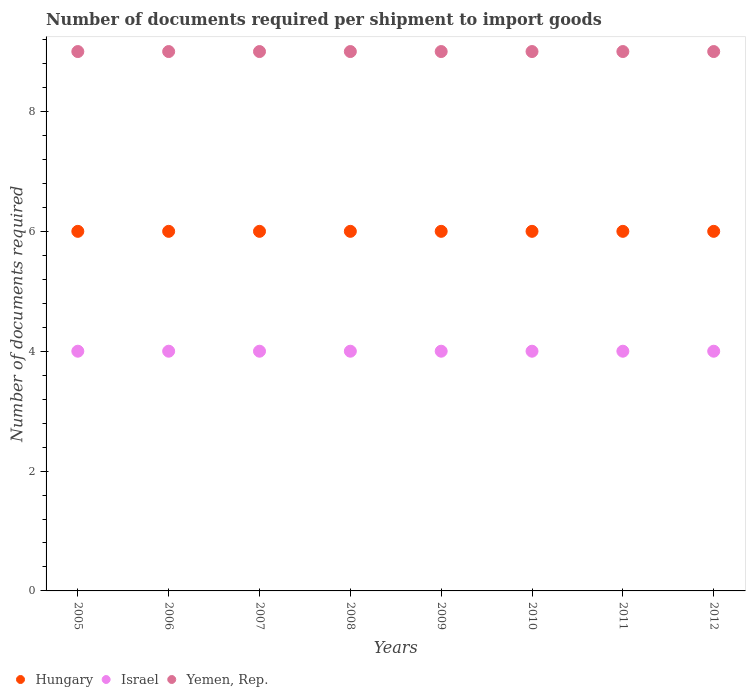Is the number of dotlines equal to the number of legend labels?
Provide a succinct answer. Yes. What is the number of documents required per shipment to import goods in Yemen, Rep. in 2012?
Give a very brief answer. 9. Across all years, what is the maximum number of documents required per shipment to import goods in Yemen, Rep.?
Make the answer very short. 9. Across all years, what is the minimum number of documents required per shipment to import goods in Israel?
Your answer should be compact. 4. In which year was the number of documents required per shipment to import goods in Yemen, Rep. maximum?
Offer a very short reply. 2005. What is the total number of documents required per shipment to import goods in Hungary in the graph?
Make the answer very short. 48. What is the difference between the number of documents required per shipment to import goods in Hungary in 2008 and that in 2010?
Provide a succinct answer. 0. What is the difference between the number of documents required per shipment to import goods in Yemen, Rep. in 2011 and the number of documents required per shipment to import goods in Hungary in 2009?
Provide a short and direct response. 3. What is the average number of documents required per shipment to import goods in Hungary per year?
Give a very brief answer. 6. In the year 2006, what is the difference between the number of documents required per shipment to import goods in Hungary and number of documents required per shipment to import goods in Yemen, Rep.?
Ensure brevity in your answer.  -3. Is the difference between the number of documents required per shipment to import goods in Hungary in 2005 and 2007 greater than the difference between the number of documents required per shipment to import goods in Yemen, Rep. in 2005 and 2007?
Offer a terse response. No. What is the difference between the highest and the second highest number of documents required per shipment to import goods in Israel?
Your answer should be compact. 0. What is the difference between the highest and the lowest number of documents required per shipment to import goods in Hungary?
Provide a succinct answer. 0. In how many years, is the number of documents required per shipment to import goods in Israel greater than the average number of documents required per shipment to import goods in Israel taken over all years?
Provide a short and direct response. 0. Is the sum of the number of documents required per shipment to import goods in Yemen, Rep. in 2006 and 2008 greater than the maximum number of documents required per shipment to import goods in Israel across all years?
Provide a short and direct response. Yes. Does the number of documents required per shipment to import goods in Israel monotonically increase over the years?
Give a very brief answer. No. Are the values on the major ticks of Y-axis written in scientific E-notation?
Your response must be concise. No. Does the graph contain any zero values?
Make the answer very short. No. How many legend labels are there?
Ensure brevity in your answer.  3. How are the legend labels stacked?
Provide a short and direct response. Horizontal. What is the title of the graph?
Ensure brevity in your answer.  Number of documents required per shipment to import goods. What is the label or title of the X-axis?
Offer a very short reply. Years. What is the label or title of the Y-axis?
Offer a very short reply. Number of documents required. What is the Number of documents required of Hungary in 2005?
Your answer should be compact. 6. What is the Number of documents required in Yemen, Rep. in 2005?
Ensure brevity in your answer.  9. What is the Number of documents required in Hungary in 2006?
Your answer should be very brief. 6. What is the Number of documents required in Israel in 2006?
Keep it short and to the point. 4. What is the Number of documents required in Yemen, Rep. in 2006?
Your answer should be compact. 9. What is the Number of documents required of Hungary in 2008?
Your response must be concise. 6. What is the Number of documents required in Israel in 2008?
Ensure brevity in your answer.  4. What is the Number of documents required of Israel in 2010?
Provide a short and direct response. 4. Across all years, what is the maximum Number of documents required of Israel?
Provide a succinct answer. 4. Across all years, what is the maximum Number of documents required in Yemen, Rep.?
Offer a very short reply. 9. Across all years, what is the minimum Number of documents required in Hungary?
Your answer should be very brief. 6. Across all years, what is the minimum Number of documents required of Israel?
Keep it short and to the point. 4. Across all years, what is the minimum Number of documents required in Yemen, Rep.?
Your answer should be compact. 9. What is the total Number of documents required in Yemen, Rep. in the graph?
Your answer should be very brief. 72. What is the difference between the Number of documents required of Yemen, Rep. in 2005 and that in 2006?
Provide a short and direct response. 0. What is the difference between the Number of documents required of Hungary in 2005 and that in 2007?
Give a very brief answer. 0. What is the difference between the Number of documents required of Israel in 2005 and that in 2007?
Provide a short and direct response. 0. What is the difference between the Number of documents required in Hungary in 2005 and that in 2008?
Offer a very short reply. 0. What is the difference between the Number of documents required of Israel in 2005 and that in 2008?
Make the answer very short. 0. What is the difference between the Number of documents required in Yemen, Rep. in 2005 and that in 2008?
Give a very brief answer. 0. What is the difference between the Number of documents required in Yemen, Rep. in 2005 and that in 2009?
Make the answer very short. 0. What is the difference between the Number of documents required in Hungary in 2005 and that in 2010?
Your response must be concise. 0. What is the difference between the Number of documents required in Yemen, Rep. in 2005 and that in 2010?
Give a very brief answer. 0. What is the difference between the Number of documents required of Hungary in 2005 and that in 2011?
Provide a succinct answer. 0. What is the difference between the Number of documents required of Israel in 2005 and that in 2011?
Offer a very short reply. 0. What is the difference between the Number of documents required of Hungary in 2005 and that in 2012?
Ensure brevity in your answer.  0. What is the difference between the Number of documents required in Yemen, Rep. in 2005 and that in 2012?
Give a very brief answer. 0. What is the difference between the Number of documents required of Hungary in 2006 and that in 2007?
Ensure brevity in your answer.  0. What is the difference between the Number of documents required in Yemen, Rep. in 2006 and that in 2007?
Offer a very short reply. 0. What is the difference between the Number of documents required in Israel in 2006 and that in 2008?
Provide a succinct answer. 0. What is the difference between the Number of documents required in Hungary in 2006 and that in 2009?
Provide a succinct answer. 0. What is the difference between the Number of documents required in Israel in 2006 and that in 2009?
Ensure brevity in your answer.  0. What is the difference between the Number of documents required in Yemen, Rep. in 2006 and that in 2010?
Provide a succinct answer. 0. What is the difference between the Number of documents required of Hungary in 2006 and that in 2011?
Your answer should be very brief. 0. What is the difference between the Number of documents required in Israel in 2006 and that in 2011?
Offer a terse response. 0. What is the difference between the Number of documents required in Yemen, Rep. in 2006 and that in 2011?
Keep it short and to the point. 0. What is the difference between the Number of documents required of Hungary in 2007 and that in 2008?
Your response must be concise. 0. What is the difference between the Number of documents required in Yemen, Rep. in 2007 and that in 2008?
Your answer should be compact. 0. What is the difference between the Number of documents required in Hungary in 2007 and that in 2009?
Your response must be concise. 0. What is the difference between the Number of documents required in Yemen, Rep. in 2007 and that in 2009?
Make the answer very short. 0. What is the difference between the Number of documents required of Hungary in 2007 and that in 2010?
Provide a short and direct response. 0. What is the difference between the Number of documents required of Yemen, Rep. in 2007 and that in 2010?
Your response must be concise. 0. What is the difference between the Number of documents required in Hungary in 2007 and that in 2011?
Your response must be concise. 0. What is the difference between the Number of documents required in Israel in 2007 and that in 2011?
Provide a succinct answer. 0. What is the difference between the Number of documents required of Yemen, Rep. in 2007 and that in 2011?
Your answer should be compact. 0. What is the difference between the Number of documents required of Hungary in 2007 and that in 2012?
Ensure brevity in your answer.  0. What is the difference between the Number of documents required of Israel in 2007 and that in 2012?
Keep it short and to the point. 0. What is the difference between the Number of documents required of Yemen, Rep. in 2007 and that in 2012?
Your response must be concise. 0. What is the difference between the Number of documents required in Hungary in 2008 and that in 2010?
Your response must be concise. 0. What is the difference between the Number of documents required of Yemen, Rep. in 2008 and that in 2010?
Offer a terse response. 0. What is the difference between the Number of documents required in Hungary in 2008 and that in 2011?
Keep it short and to the point. 0. What is the difference between the Number of documents required in Yemen, Rep. in 2008 and that in 2011?
Make the answer very short. 0. What is the difference between the Number of documents required in Yemen, Rep. in 2008 and that in 2012?
Provide a short and direct response. 0. What is the difference between the Number of documents required in Hungary in 2009 and that in 2010?
Offer a terse response. 0. What is the difference between the Number of documents required of Israel in 2009 and that in 2010?
Provide a short and direct response. 0. What is the difference between the Number of documents required of Hungary in 2009 and that in 2011?
Keep it short and to the point. 0. What is the difference between the Number of documents required of Yemen, Rep. in 2009 and that in 2011?
Your answer should be compact. 0. What is the difference between the Number of documents required of Hungary in 2009 and that in 2012?
Your answer should be compact. 0. What is the difference between the Number of documents required of Israel in 2009 and that in 2012?
Your answer should be very brief. 0. What is the difference between the Number of documents required of Yemen, Rep. in 2009 and that in 2012?
Offer a terse response. 0. What is the difference between the Number of documents required of Israel in 2010 and that in 2011?
Your answer should be compact. 0. What is the difference between the Number of documents required of Hungary in 2010 and that in 2012?
Your answer should be compact. 0. What is the difference between the Number of documents required in Yemen, Rep. in 2010 and that in 2012?
Provide a succinct answer. 0. What is the difference between the Number of documents required of Hungary in 2011 and that in 2012?
Offer a very short reply. 0. What is the difference between the Number of documents required of Hungary in 2005 and the Number of documents required of Israel in 2006?
Make the answer very short. 2. What is the difference between the Number of documents required of Hungary in 2005 and the Number of documents required of Yemen, Rep. in 2007?
Keep it short and to the point. -3. What is the difference between the Number of documents required in Israel in 2005 and the Number of documents required in Yemen, Rep. in 2007?
Give a very brief answer. -5. What is the difference between the Number of documents required of Hungary in 2005 and the Number of documents required of Yemen, Rep. in 2008?
Ensure brevity in your answer.  -3. What is the difference between the Number of documents required of Israel in 2005 and the Number of documents required of Yemen, Rep. in 2008?
Make the answer very short. -5. What is the difference between the Number of documents required in Hungary in 2005 and the Number of documents required in Yemen, Rep. in 2009?
Give a very brief answer. -3. What is the difference between the Number of documents required of Hungary in 2005 and the Number of documents required of Yemen, Rep. in 2010?
Your response must be concise. -3. What is the difference between the Number of documents required in Hungary in 2005 and the Number of documents required in Israel in 2011?
Offer a very short reply. 2. What is the difference between the Number of documents required in Hungary in 2005 and the Number of documents required in Yemen, Rep. in 2012?
Ensure brevity in your answer.  -3. What is the difference between the Number of documents required of Israel in 2005 and the Number of documents required of Yemen, Rep. in 2012?
Your answer should be very brief. -5. What is the difference between the Number of documents required in Hungary in 2006 and the Number of documents required in Israel in 2007?
Make the answer very short. 2. What is the difference between the Number of documents required of Hungary in 2006 and the Number of documents required of Yemen, Rep. in 2007?
Give a very brief answer. -3. What is the difference between the Number of documents required in Hungary in 2006 and the Number of documents required in Yemen, Rep. in 2008?
Provide a short and direct response. -3. What is the difference between the Number of documents required in Israel in 2006 and the Number of documents required in Yemen, Rep. in 2008?
Provide a short and direct response. -5. What is the difference between the Number of documents required of Hungary in 2006 and the Number of documents required of Yemen, Rep. in 2009?
Offer a terse response. -3. What is the difference between the Number of documents required of Israel in 2006 and the Number of documents required of Yemen, Rep. in 2009?
Your answer should be compact. -5. What is the difference between the Number of documents required of Hungary in 2006 and the Number of documents required of Israel in 2010?
Ensure brevity in your answer.  2. What is the difference between the Number of documents required of Hungary in 2006 and the Number of documents required of Yemen, Rep. in 2010?
Your answer should be very brief. -3. What is the difference between the Number of documents required of Israel in 2006 and the Number of documents required of Yemen, Rep. in 2010?
Provide a short and direct response. -5. What is the difference between the Number of documents required in Hungary in 2006 and the Number of documents required in Israel in 2011?
Your answer should be very brief. 2. What is the difference between the Number of documents required in Israel in 2006 and the Number of documents required in Yemen, Rep. in 2011?
Offer a very short reply. -5. What is the difference between the Number of documents required in Hungary in 2006 and the Number of documents required in Yemen, Rep. in 2012?
Ensure brevity in your answer.  -3. What is the difference between the Number of documents required in Israel in 2006 and the Number of documents required in Yemen, Rep. in 2012?
Provide a short and direct response. -5. What is the difference between the Number of documents required of Hungary in 2007 and the Number of documents required of Israel in 2008?
Make the answer very short. 2. What is the difference between the Number of documents required in Israel in 2007 and the Number of documents required in Yemen, Rep. in 2008?
Provide a succinct answer. -5. What is the difference between the Number of documents required in Hungary in 2007 and the Number of documents required in Israel in 2009?
Your answer should be compact. 2. What is the difference between the Number of documents required in Hungary in 2007 and the Number of documents required in Yemen, Rep. in 2009?
Keep it short and to the point. -3. What is the difference between the Number of documents required in Israel in 2007 and the Number of documents required in Yemen, Rep. in 2009?
Make the answer very short. -5. What is the difference between the Number of documents required in Hungary in 2007 and the Number of documents required in Israel in 2010?
Provide a short and direct response. 2. What is the difference between the Number of documents required of Hungary in 2007 and the Number of documents required of Yemen, Rep. in 2010?
Provide a short and direct response. -3. What is the difference between the Number of documents required in Hungary in 2007 and the Number of documents required in Israel in 2011?
Your answer should be compact. 2. What is the difference between the Number of documents required of Hungary in 2007 and the Number of documents required of Yemen, Rep. in 2011?
Your answer should be very brief. -3. What is the difference between the Number of documents required in Hungary in 2007 and the Number of documents required in Israel in 2012?
Make the answer very short. 2. What is the difference between the Number of documents required of Hungary in 2007 and the Number of documents required of Yemen, Rep. in 2012?
Your answer should be very brief. -3. What is the difference between the Number of documents required in Hungary in 2008 and the Number of documents required in Israel in 2009?
Your answer should be very brief. 2. What is the difference between the Number of documents required of Hungary in 2008 and the Number of documents required of Yemen, Rep. in 2009?
Provide a short and direct response. -3. What is the difference between the Number of documents required in Israel in 2008 and the Number of documents required in Yemen, Rep. in 2010?
Offer a very short reply. -5. What is the difference between the Number of documents required of Israel in 2008 and the Number of documents required of Yemen, Rep. in 2011?
Ensure brevity in your answer.  -5. What is the difference between the Number of documents required of Hungary in 2008 and the Number of documents required of Israel in 2012?
Provide a short and direct response. 2. What is the difference between the Number of documents required in Hungary in 2009 and the Number of documents required in Israel in 2010?
Offer a very short reply. 2. What is the difference between the Number of documents required in Hungary in 2009 and the Number of documents required in Yemen, Rep. in 2011?
Offer a terse response. -3. What is the difference between the Number of documents required of Israel in 2009 and the Number of documents required of Yemen, Rep. in 2011?
Provide a succinct answer. -5. What is the difference between the Number of documents required of Israel in 2010 and the Number of documents required of Yemen, Rep. in 2011?
Keep it short and to the point. -5. What is the difference between the Number of documents required in Hungary in 2010 and the Number of documents required in Yemen, Rep. in 2012?
Ensure brevity in your answer.  -3. What is the difference between the Number of documents required in Hungary in 2011 and the Number of documents required in Israel in 2012?
Your answer should be very brief. 2. What is the difference between the Number of documents required in Israel in 2011 and the Number of documents required in Yemen, Rep. in 2012?
Your response must be concise. -5. What is the average Number of documents required in Israel per year?
Make the answer very short. 4. What is the average Number of documents required of Yemen, Rep. per year?
Offer a very short reply. 9. In the year 2005, what is the difference between the Number of documents required of Hungary and Number of documents required of Israel?
Offer a very short reply. 2. In the year 2005, what is the difference between the Number of documents required in Hungary and Number of documents required in Yemen, Rep.?
Your response must be concise. -3. In the year 2006, what is the difference between the Number of documents required in Hungary and Number of documents required in Israel?
Make the answer very short. 2. In the year 2007, what is the difference between the Number of documents required of Hungary and Number of documents required of Israel?
Offer a very short reply. 2. In the year 2007, what is the difference between the Number of documents required of Israel and Number of documents required of Yemen, Rep.?
Your answer should be very brief. -5. In the year 2008, what is the difference between the Number of documents required in Hungary and Number of documents required in Yemen, Rep.?
Keep it short and to the point. -3. In the year 2009, what is the difference between the Number of documents required of Hungary and Number of documents required of Israel?
Your answer should be very brief. 2. In the year 2009, what is the difference between the Number of documents required in Hungary and Number of documents required in Yemen, Rep.?
Your answer should be very brief. -3. In the year 2010, what is the difference between the Number of documents required in Hungary and Number of documents required in Israel?
Provide a succinct answer. 2. In the year 2011, what is the difference between the Number of documents required of Hungary and Number of documents required of Israel?
Provide a short and direct response. 2. In the year 2011, what is the difference between the Number of documents required of Hungary and Number of documents required of Yemen, Rep.?
Your response must be concise. -3. In the year 2011, what is the difference between the Number of documents required in Israel and Number of documents required in Yemen, Rep.?
Offer a terse response. -5. In the year 2012, what is the difference between the Number of documents required of Hungary and Number of documents required of Israel?
Your response must be concise. 2. In the year 2012, what is the difference between the Number of documents required of Hungary and Number of documents required of Yemen, Rep.?
Make the answer very short. -3. What is the ratio of the Number of documents required of Hungary in 2005 to that in 2006?
Provide a short and direct response. 1. What is the ratio of the Number of documents required in Yemen, Rep. in 2005 to that in 2006?
Your response must be concise. 1. What is the ratio of the Number of documents required in Hungary in 2005 to that in 2007?
Offer a very short reply. 1. What is the ratio of the Number of documents required of Yemen, Rep. in 2005 to that in 2007?
Offer a terse response. 1. What is the ratio of the Number of documents required in Hungary in 2005 to that in 2008?
Keep it short and to the point. 1. What is the ratio of the Number of documents required in Israel in 2005 to that in 2009?
Provide a succinct answer. 1. What is the ratio of the Number of documents required of Yemen, Rep. in 2005 to that in 2009?
Your answer should be very brief. 1. What is the ratio of the Number of documents required of Yemen, Rep. in 2005 to that in 2010?
Offer a terse response. 1. What is the ratio of the Number of documents required in Hungary in 2005 to that in 2011?
Provide a succinct answer. 1. What is the ratio of the Number of documents required in Israel in 2005 to that in 2011?
Ensure brevity in your answer.  1. What is the ratio of the Number of documents required in Hungary in 2005 to that in 2012?
Provide a succinct answer. 1. What is the ratio of the Number of documents required of Israel in 2005 to that in 2012?
Your answer should be compact. 1. What is the ratio of the Number of documents required in Yemen, Rep. in 2005 to that in 2012?
Offer a very short reply. 1. What is the ratio of the Number of documents required of Yemen, Rep. in 2006 to that in 2007?
Keep it short and to the point. 1. What is the ratio of the Number of documents required of Hungary in 2006 to that in 2008?
Give a very brief answer. 1. What is the ratio of the Number of documents required of Hungary in 2006 to that in 2009?
Keep it short and to the point. 1. What is the ratio of the Number of documents required in Israel in 2006 to that in 2009?
Provide a short and direct response. 1. What is the ratio of the Number of documents required in Yemen, Rep. in 2006 to that in 2009?
Your response must be concise. 1. What is the ratio of the Number of documents required in Hungary in 2006 to that in 2011?
Make the answer very short. 1. What is the ratio of the Number of documents required of Israel in 2006 to that in 2011?
Offer a terse response. 1. What is the ratio of the Number of documents required of Hungary in 2006 to that in 2012?
Your answer should be very brief. 1. What is the ratio of the Number of documents required of Israel in 2006 to that in 2012?
Ensure brevity in your answer.  1. What is the ratio of the Number of documents required of Yemen, Rep. in 2006 to that in 2012?
Your answer should be very brief. 1. What is the ratio of the Number of documents required in Yemen, Rep. in 2007 to that in 2008?
Keep it short and to the point. 1. What is the ratio of the Number of documents required in Israel in 2007 to that in 2009?
Keep it short and to the point. 1. What is the ratio of the Number of documents required in Yemen, Rep. in 2007 to that in 2010?
Provide a short and direct response. 1. What is the ratio of the Number of documents required in Hungary in 2007 to that in 2011?
Offer a very short reply. 1. What is the ratio of the Number of documents required of Israel in 2007 to that in 2011?
Give a very brief answer. 1. What is the ratio of the Number of documents required in Hungary in 2007 to that in 2012?
Provide a short and direct response. 1. What is the ratio of the Number of documents required in Israel in 2007 to that in 2012?
Offer a very short reply. 1. What is the ratio of the Number of documents required of Yemen, Rep. in 2007 to that in 2012?
Offer a very short reply. 1. What is the ratio of the Number of documents required of Hungary in 2008 to that in 2009?
Keep it short and to the point. 1. What is the ratio of the Number of documents required in Israel in 2008 to that in 2009?
Give a very brief answer. 1. What is the ratio of the Number of documents required in Hungary in 2008 to that in 2010?
Your answer should be very brief. 1. What is the ratio of the Number of documents required in Israel in 2008 to that in 2010?
Your answer should be compact. 1. What is the ratio of the Number of documents required of Yemen, Rep. in 2008 to that in 2010?
Offer a very short reply. 1. What is the ratio of the Number of documents required of Israel in 2008 to that in 2011?
Provide a short and direct response. 1. What is the ratio of the Number of documents required in Yemen, Rep. in 2008 to that in 2011?
Ensure brevity in your answer.  1. What is the ratio of the Number of documents required in Yemen, Rep. in 2008 to that in 2012?
Your answer should be very brief. 1. What is the ratio of the Number of documents required of Hungary in 2009 to that in 2010?
Ensure brevity in your answer.  1. What is the ratio of the Number of documents required of Yemen, Rep. in 2009 to that in 2010?
Your answer should be very brief. 1. What is the ratio of the Number of documents required of Yemen, Rep. in 2009 to that in 2012?
Make the answer very short. 1. What is the ratio of the Number of documents required in Yemen, Rep. in 2010 to that in 2012?
Keep it short and to the point. 1. What is the ratio of the Number of documents required of Hungary in 2011 to that in 2012?
Offer a very short reply. 1. What is the ratio of the Number of documents required of Yemen, Rep. in 2011 to that in 2012?
Ensure brevity in your answer.  1. What is the difference between the highest and the second highest Number of documents required of Hungary?
Keep it short and to the point. 0. What is the difference between the highest and the second highest Number of documents required of Yemen, Rep.?
Give a very brief answer. 0. What is the difference between the highest and the lowest Number of documents required of Israel?
Offer a very short reply. 0. What is the difference between the highest and the lowest Number of documents required of Yemen, Rep.?
Provide a succinct answer. 0. 